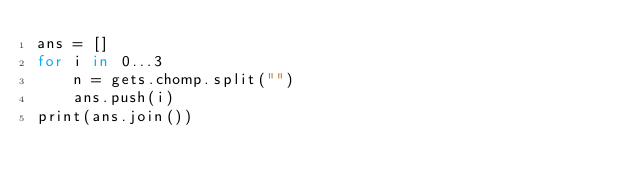Convert code to text. <code><loc_0><loc_0><loc_500><loc_500><_Ruby_>ans = []
for i in 0...3
    n = gets.chomp.split("")
    ans.push(i)
print(ans.join())</code> 